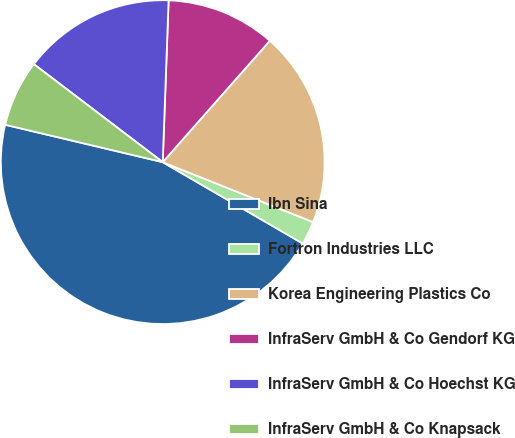Convert chart. <chart><loc_0><loc_0><loc_500><loc_500><pie_chart><fcel>Ibn Sina<fcel>Fortron Industries LLC<fcel>Korea Engineering Plastics Co<fcel>InfraServ GmbH & Co Gendorf KG<fcel>InfraServ GmbH & Co Hoechst KG<fcel>InfraServ GmbH & Co Knapsack<nl><fcel>45.33%<fcel>2.34%<fcel>19.53%<fcel>10.93%<fcel>15.23%<fcel>6.64%<nl></chart> 